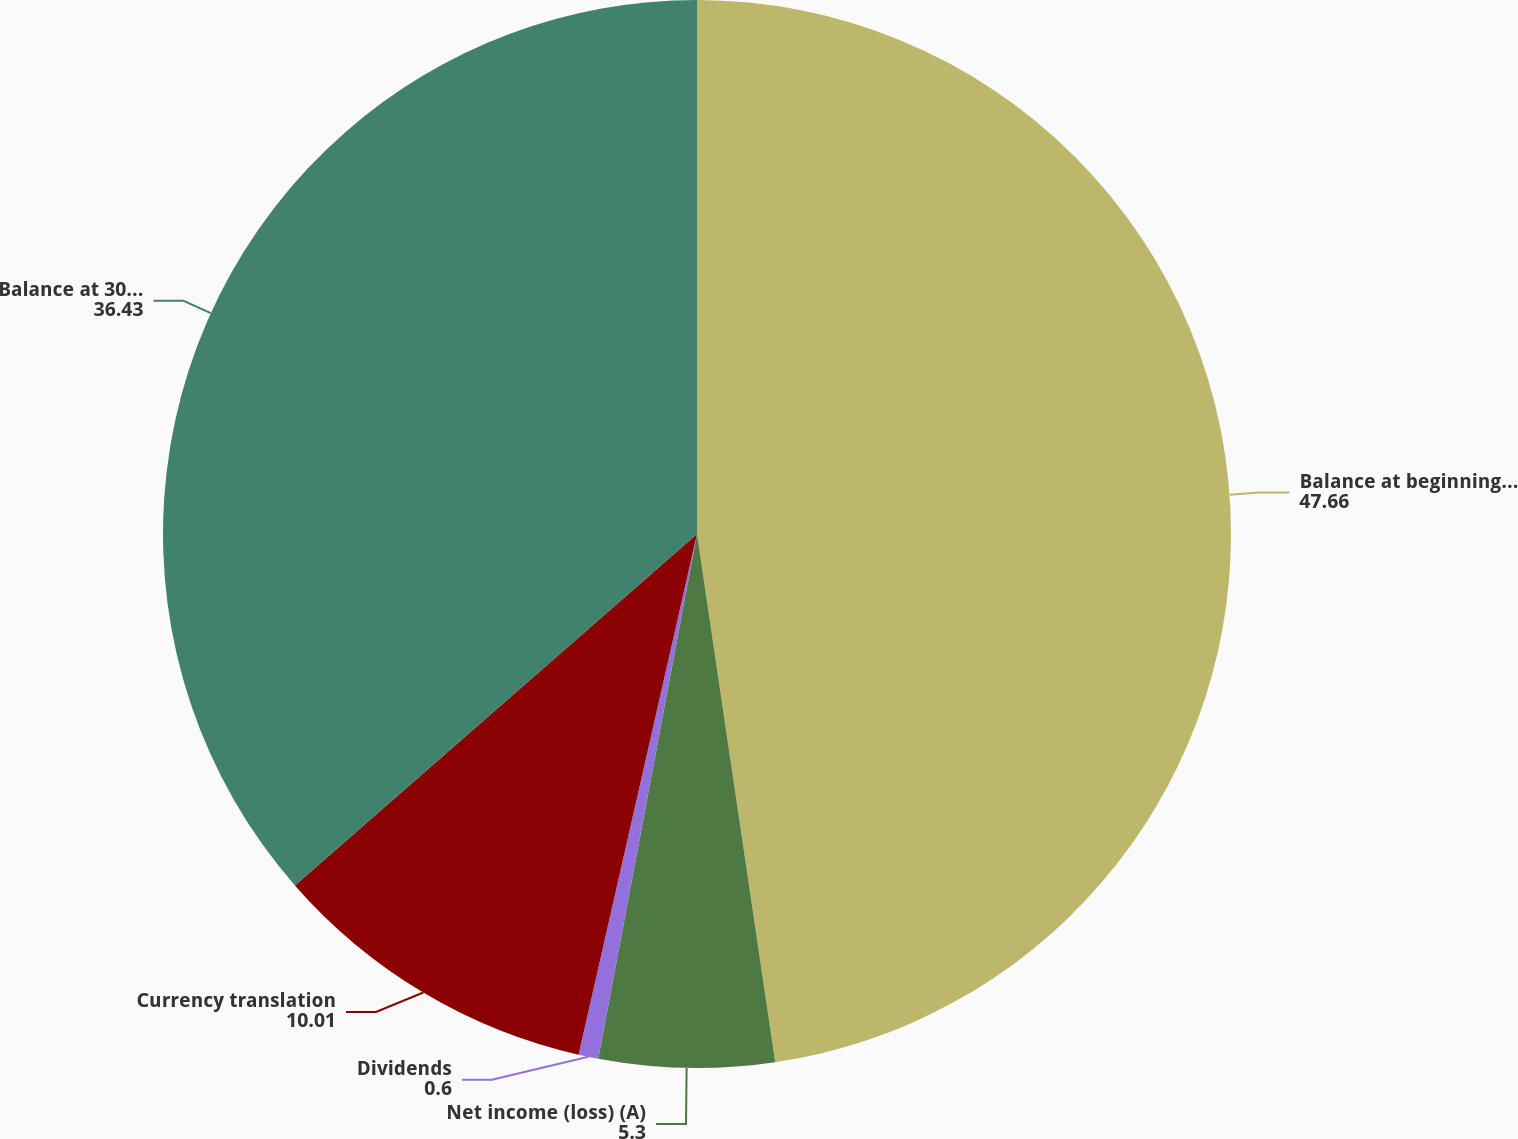Convert chart. <chart><loc_0><loc_0><loc_500><loc_500><pie_chart><fcel>Balance at beginning of year<fcel>Net income (loss) (A)<fcel>Dividends<fcel>Currency translation<fcel>Balance at 30 September<nl><fcel>47.66%<fcel>5.3%<fcel>0.6%<fcel>10.01%<fcel>36.43%<nl></chart> 